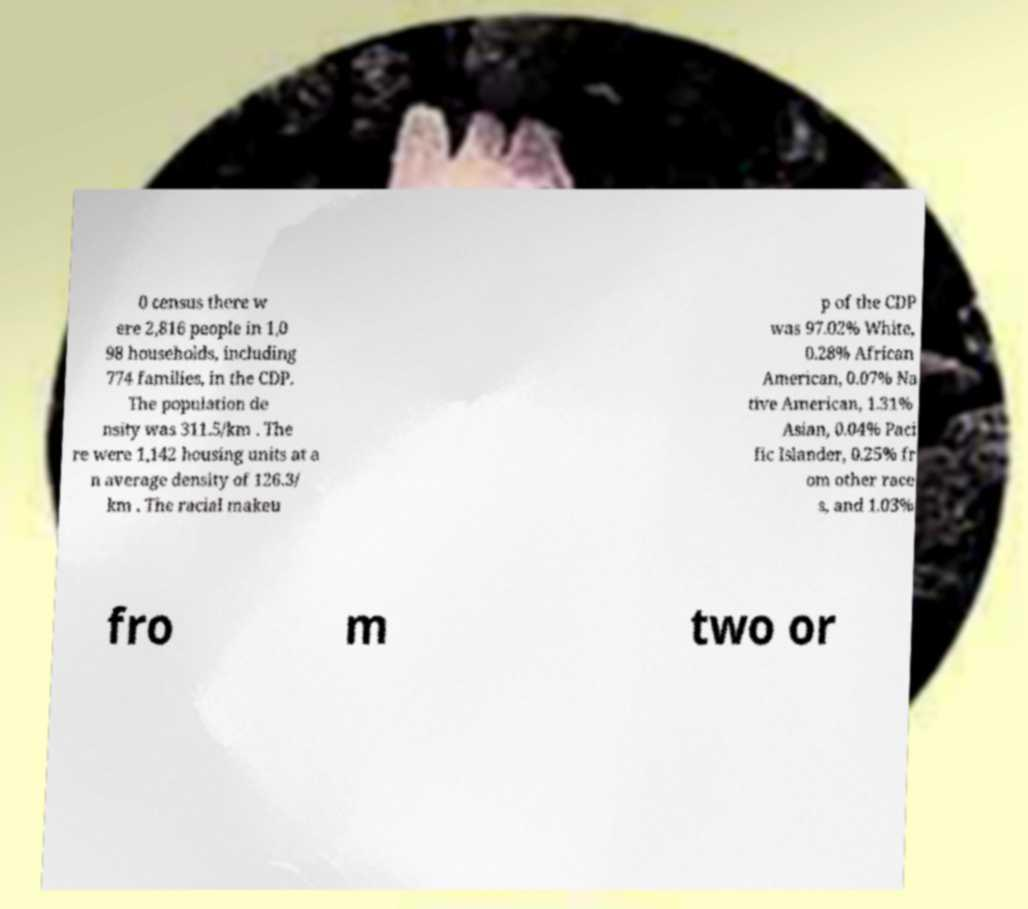Could you assist in decoding the text presented in this image and type it out clearly? 0 census there w ere 2,816 people in 1,0 98 households, including 774 families, in the CDP. The population de nsity was 311.5/km . The re were 1,142 housing units at a n average density of 126.3/ km . The racial makeu p of the CDP was 97.02% White, 0.28% African American, 0.07% Na tive American, 1.31% Asian, 0.04% Paci fic Islander, 0.25% fr om other race s, and 1.03% fro m two or 